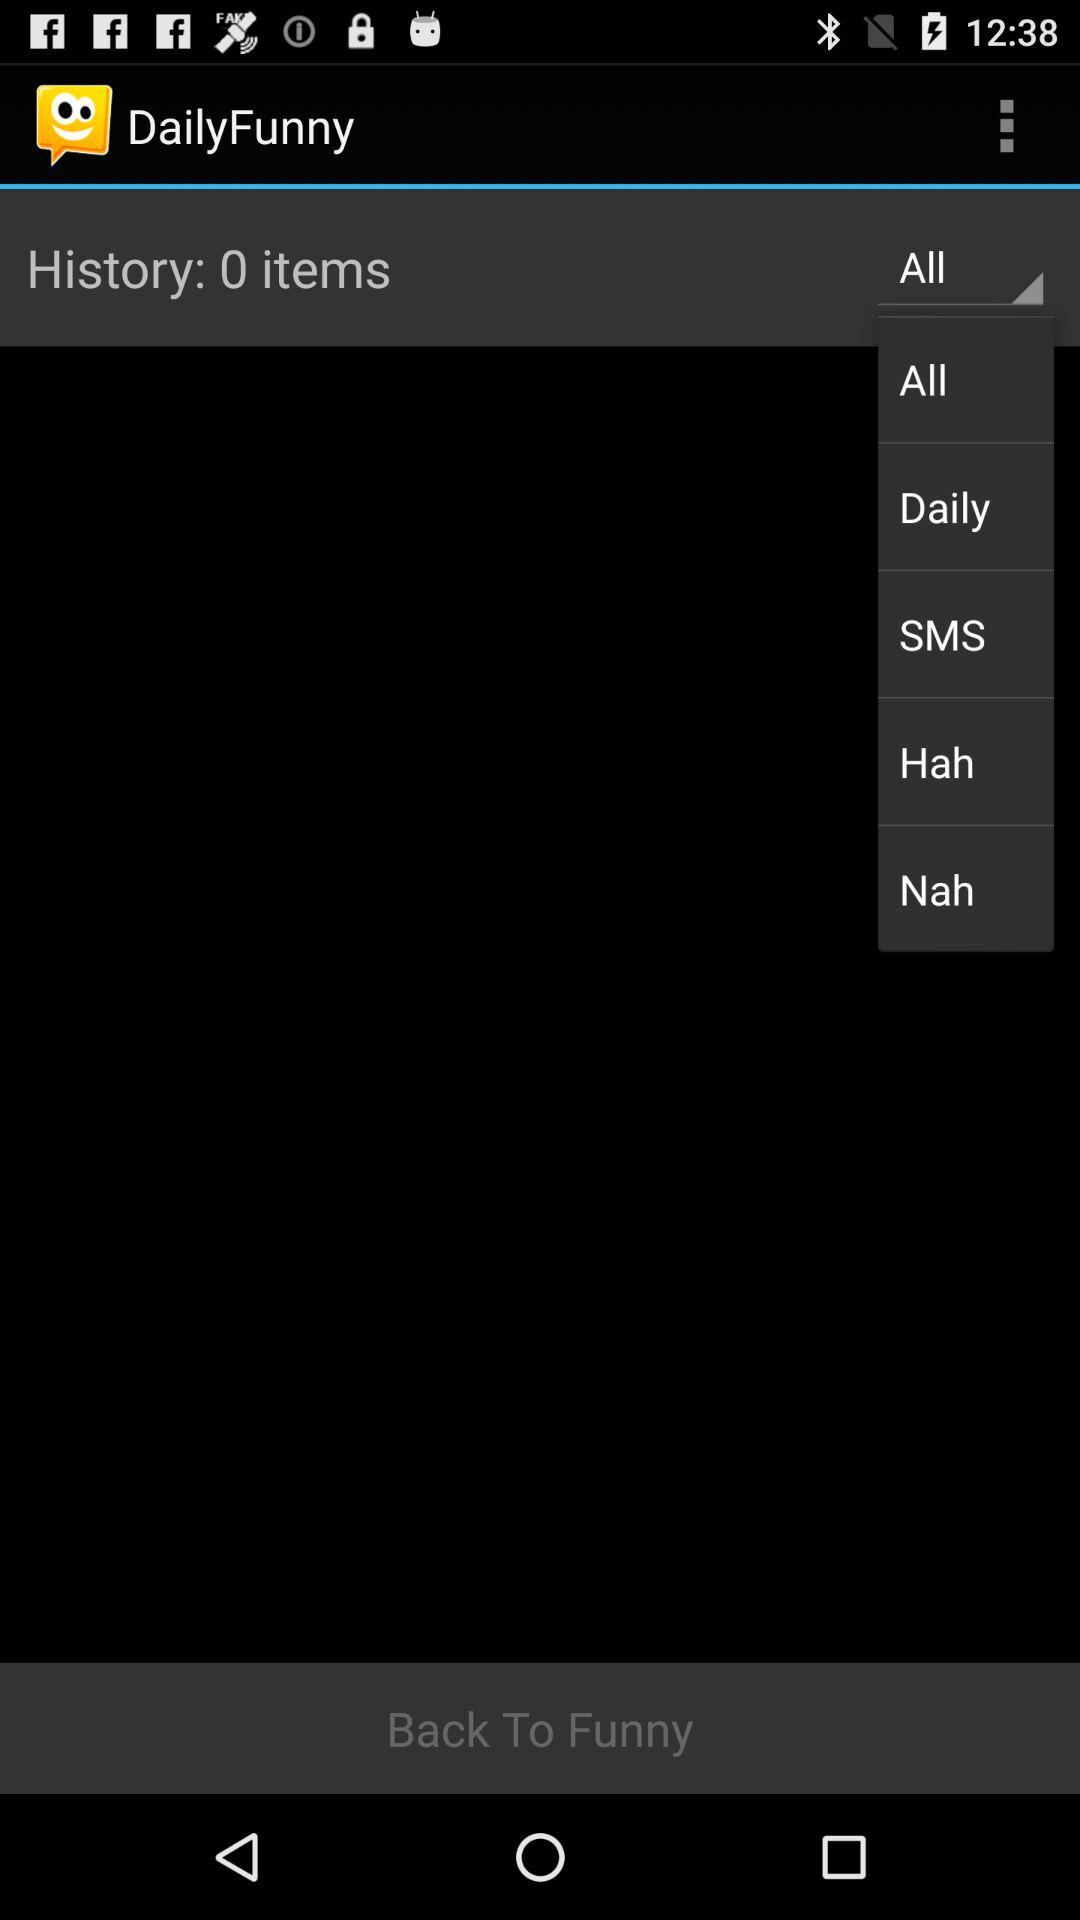What is the total number of items in "History"? The total number of items in "History" is 0. 